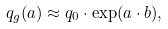Convert formula to latex. <formula><loc_0><loc_0><loc_500><loc_500>q _ { g } ( a ) \approx q _ { 0 } \cdot \exp ( a \cdot b ) ,</formula> 